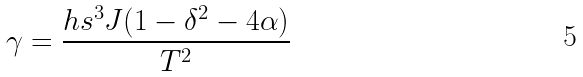<formula> <loc_0><loc_0><loc_500><loc_500>\gamma = \frac { h s ^ { 3 } J ( 1 - \delta ^ { 2 } - 4 \alpha ) } { T ^ { 2 } }</formula> 